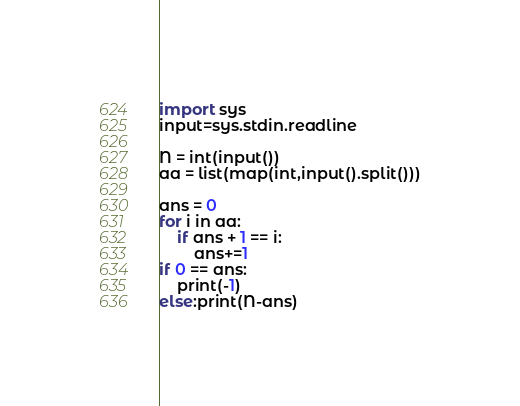<code> <loc_0><loc_0><loc_500><loc_500><_Python_>import sys
input=sys.stdin.readline

N = int(input())
aa = list(map(int,input().split()))

ans = 0
for i in aa:
	if ans + 1 == i:
		ans+=1
if 0 == ans:
	print(-1)
else:print(N-ans)</code> 